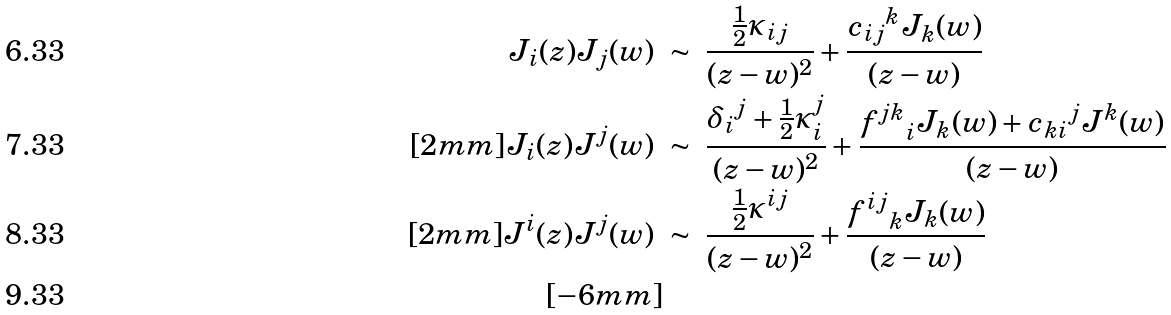Convert formula to latex. <formula><loc_0><loc_0><loc_500><loc_500>J _ { i } ( z ) J _ { j } ( w ) \ & \sim \ \frac { \frac { 1 } { 2 } \kappa _ { i j } } { ( z - w ) ^ { 2 } } + \frac { { c _ { i j } } ^ { k } J _ { k } ( w ) } { ( z - w ) } \\ [ 2 m m ] J _ { i } ( z ) J ^ { j } ( w ) \ & \sim \ \frac { { \delta _ { i } } ^ { j } + \frac { 1 } { 2 } \kappa _ { i } ^ { j } } { ( z - w ) ^ { 2 } } + \frac { { f ^ { j k } } _ { i } J _ { k } ( w ) + { { c _ { k i } } ^ { j } } J ^ { k } ( w ) } { ( z - w ) } \\ [ 2 m m ] J ^ { i } ( z ) J ^ { j } ( w ) \ & \sim \ \frac { \frac { 1 } { 2 } \kappa ^ { i j } } { ( z - w ) ^ { 2 } } + \frac { { f ^ { i j } } _ { k } J _ { k } ( w ) } { ( z - w ) } \\ [ - 6 m m ]</formula> 